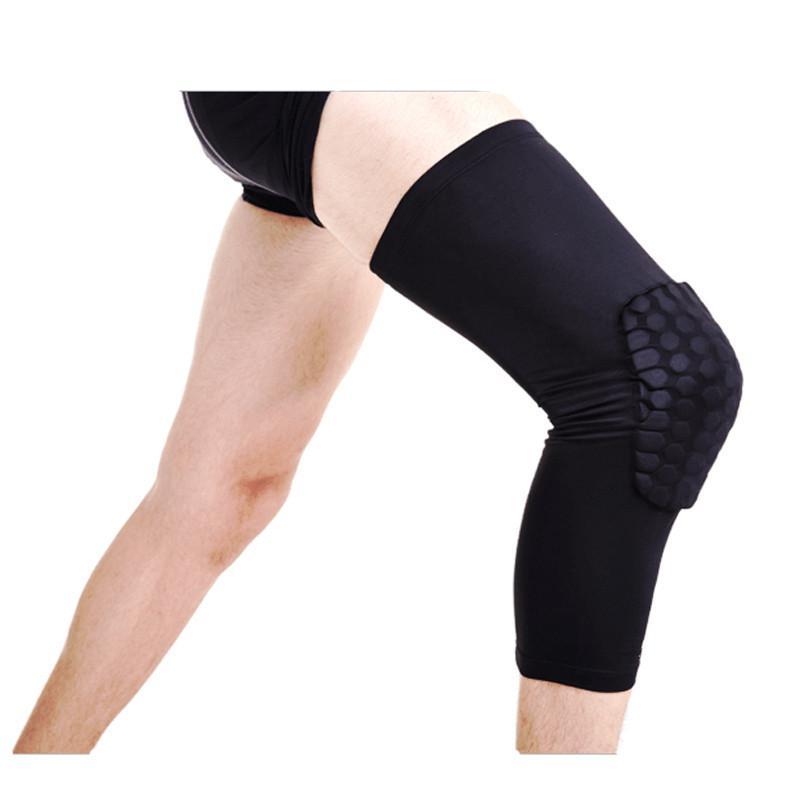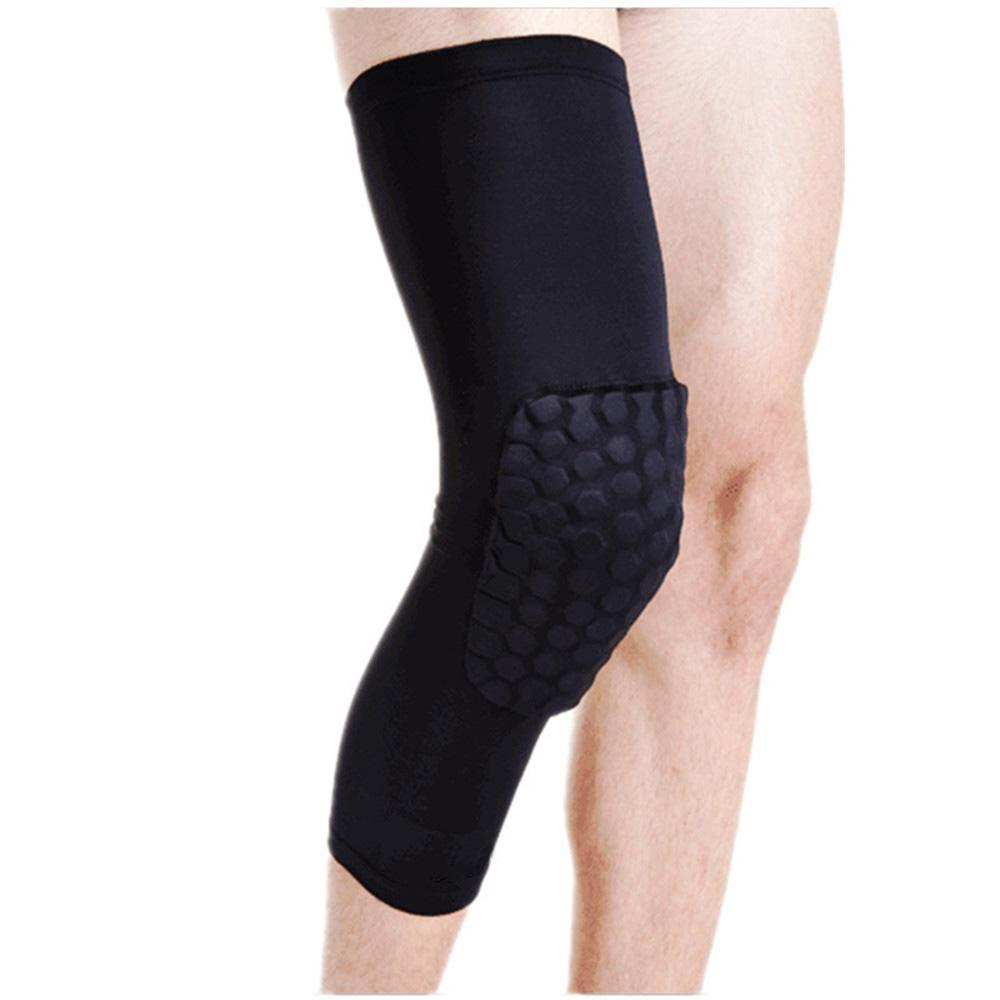The first image is the image on the left, the second image is the image on the right. Evaluate the accuracy of this statement regarding the images: "Each image shows at least one human leg, and at least one image features a long black compression wrap with a knee pad on its front worn on a leg.". Is it true? Answer yes or no. Yes. 